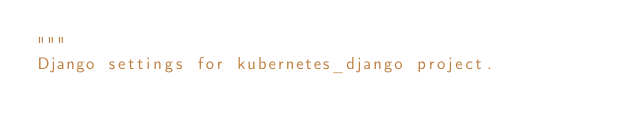Convert code to text. <code><loc_0><loc_0><loc_500><loc_500><_Python_>"""
Django settings for kubernetes_django project.
</code> 